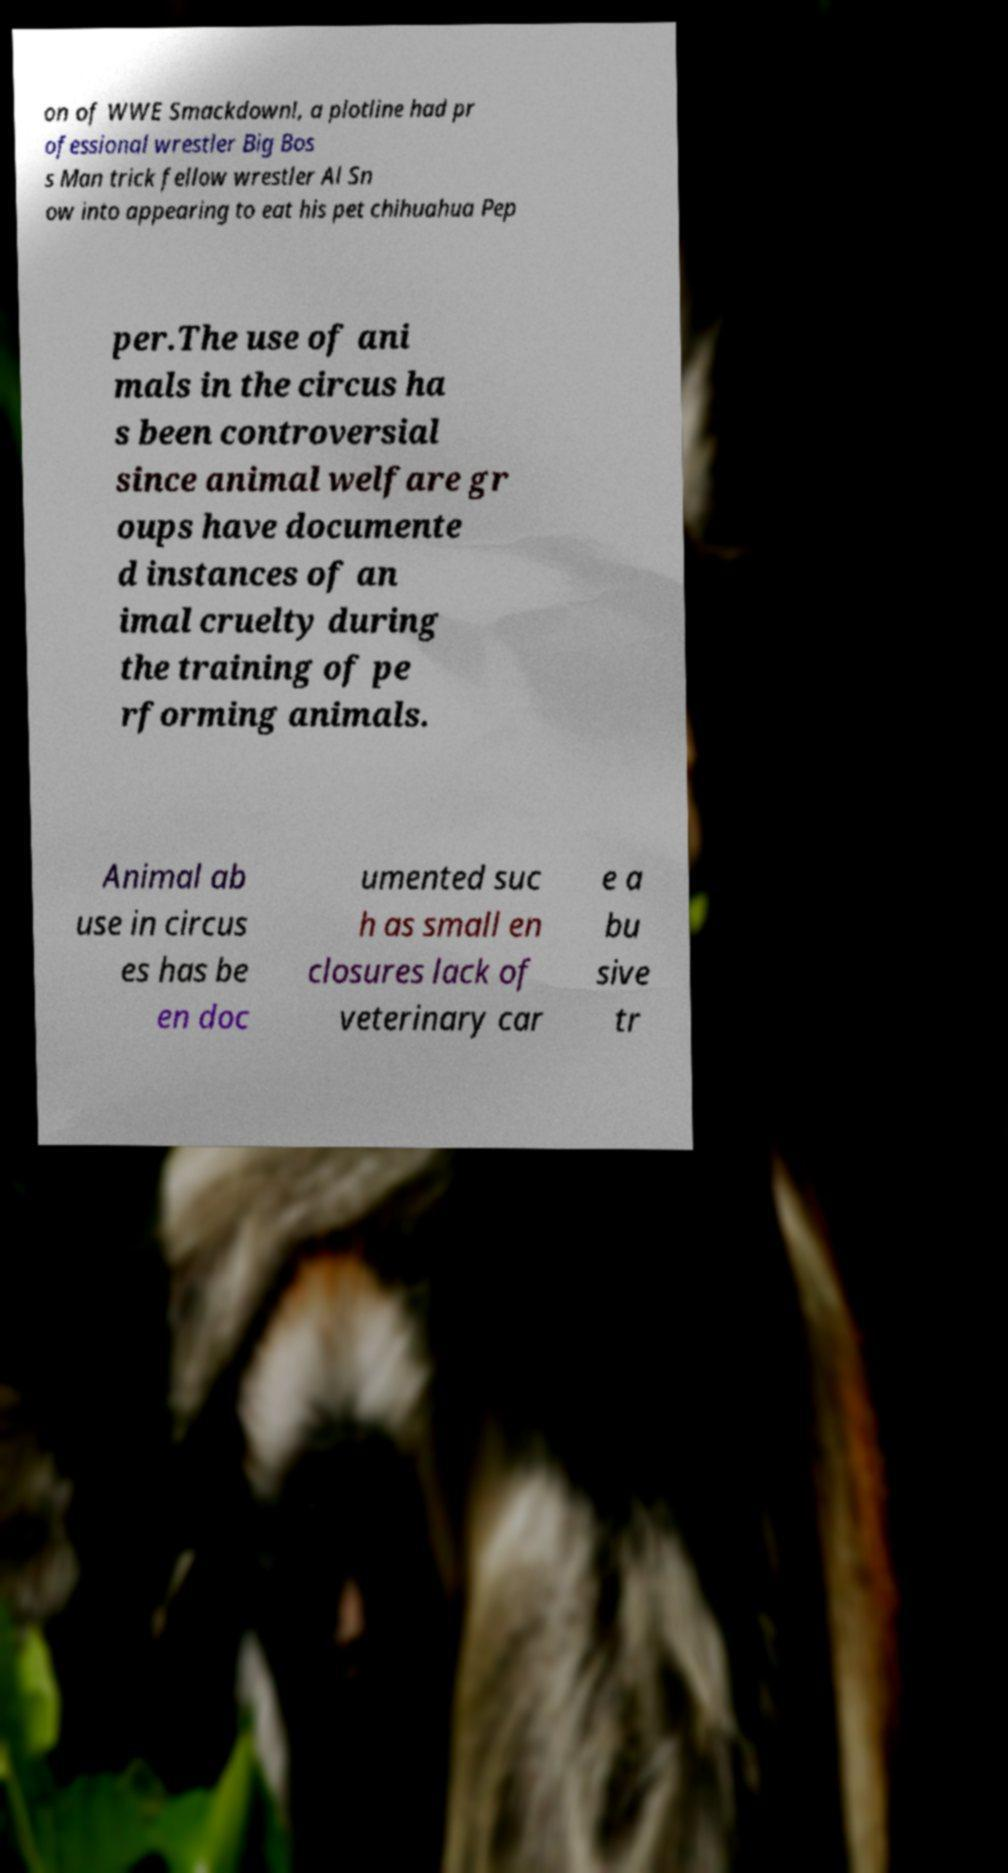What messages or text are displayed in this image? I need them in a readable, typed format. on of WWE Smackdown!, a plotline had pr ofessional wrestler Big Bos s Man trick fellow wrestler Al Sn ow into appearing to eat his pet chihuahua Pep per.The use of ani mals in the circus ha s been controversial since animal welfare gr oups have documente d instances of an imal cruelty during the training of pe rforming animals. Animal ab use in circus es has be en doc umented suc h as small en closures lack of veterinary car e a bu sive tr 